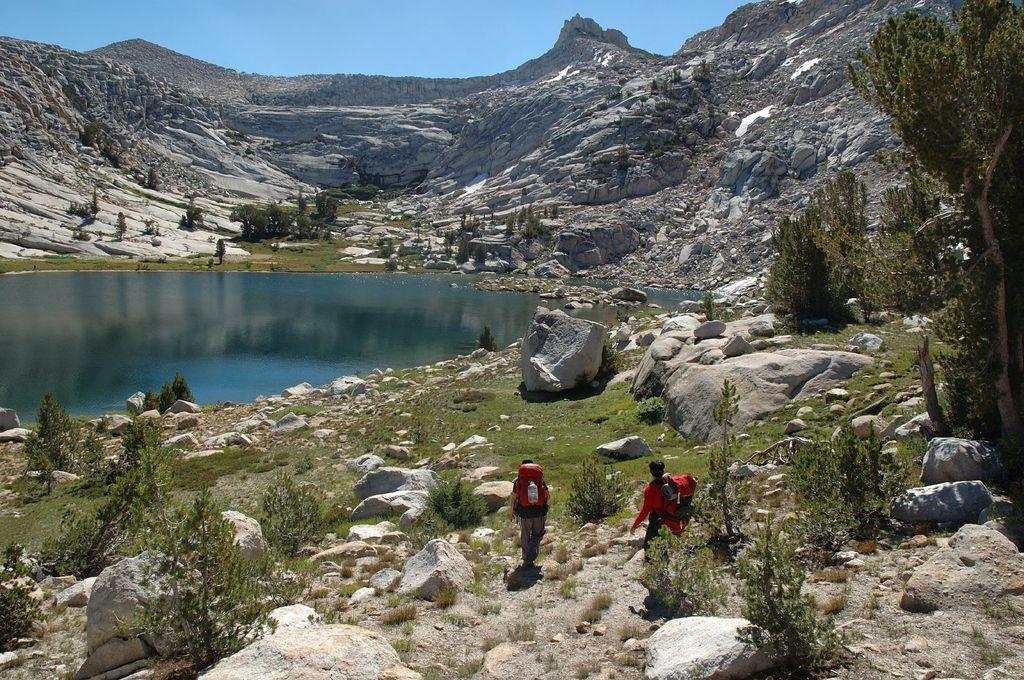In one or two sentences, can you explain what this image depicts? At the bottom of the image we can see persons walking on the ground. On the right side of the image we can see a hill, trees, rocks and grass. In the center of the image there is a water. In the background we can see trees, hills and sky. 